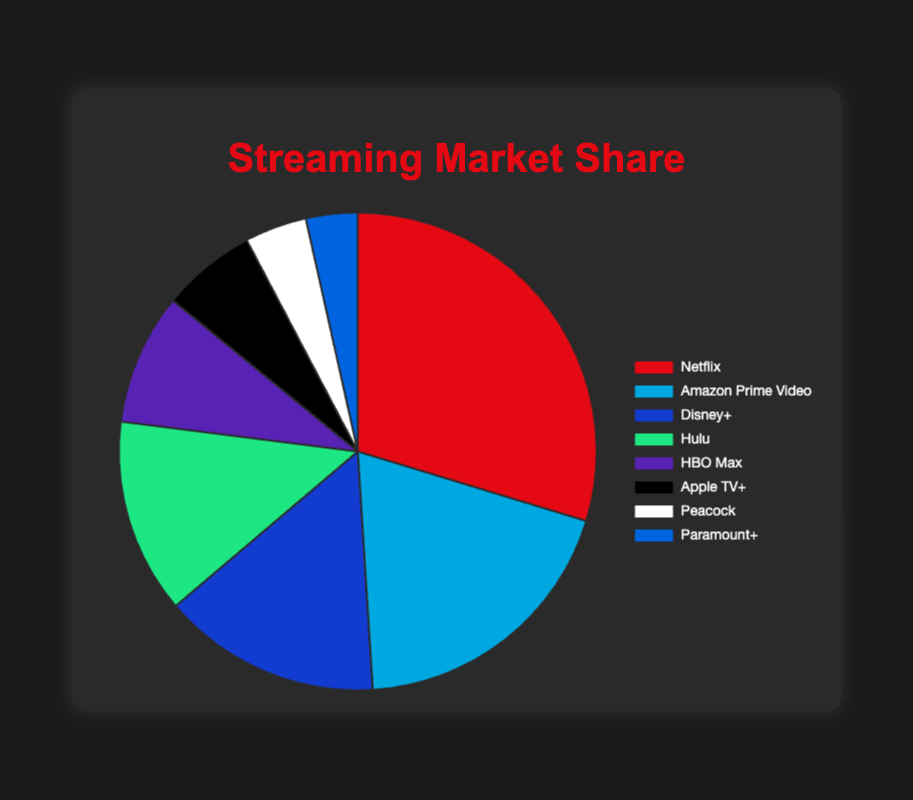Which competitor has the largest market share? The largest market share can be identified by looking at the section of the pie chart with the greatest size. Netflix occupies the largest portion of the pie.
Answer: Netflix Which two competitors have the smallest combined market share? The smallest combined market share comes from the two competitors with the smallest individual market shares. These are Peacock with 4.2% and Paramount+ with 3.5%. Adding these together gives 4.2% + 3.5% = 7.7%.
Answer: Peacock and Paramount+ How much larger is Netflix's market share compared to Amazon Prime Video's? To find the difference in market share between Netflix and Amazon Prime Video, subtract Amazon Prime Video's share from Netflix's share: 29.7% - 19.3% = 10.4%.
Answer: 10.4% Which company’s market share is closest to 15%? From the pie chart, the market share closest to 15% is Disney+ with 14.8%.
Answer: Disney+ If you combine the market shares of HBO Max and Apple TV+, how does the result compare to Hulu's market share? Sum the market shares of HBO Max (8.9%) and Apple TV+ (6.4%), which is 8.9% + 6.4% = 15.3%. Compare this combined amount to Hulu's share of 13.2%. The combined share (15.3%) is larger than Hulu's share.
Answer: Larger Which competitor has a market share between 10% and 15%? The competitor whose market share falls within the range of 10% to 15% can be identified by checking each slice of the chart for values within this range. Hulu, with a 13.2% market share, fits this criterion.
Answer: Hulu Which competitors have more than double the market share of Peacock? Peacock has a market share of 4.2%. Doubling this is 4.2% x 2 = 8.4%. Competitors with more than 8.4% are Netflix (29.7%), Amazon Prime Video (19.3%), Disney+ (14.8%), and Hulu (13.2%).
Answer: Netflix, Amazon Prime Video, Disney+, and Hulu What is the total market share of all competitors combined? To find the total market share, sum the market share percentages of all competitors: 29.7% + 19.3% + 14.8% + 13.2% + 8.9% + 6.4% + 4.2% + 3.5% = 100%.
Answer: 100% 